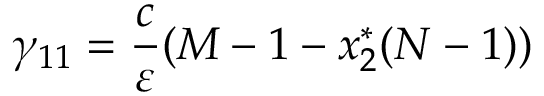Convert formula to latex. <formula><loc_0><loc_0><loc_500><loc_500>\gamma _ { 1 1 } = \frac { c } { \varepsilon } ( M - 1 - x _ { 2 } ^ { * } ( N - 1 ) )</formula> 